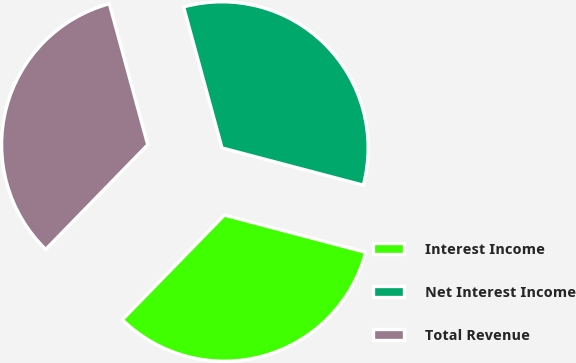Convert chart to OTSL. <chart><loc_0><loc_0><loc_500><loc_500><pie_chart><fcel>Interest Income<fcel>Net Interest Income<fcel>Total Revenue<nl><fcel>33.2%<fcel>33.33%<fcel>33.47%<nl></chart> 